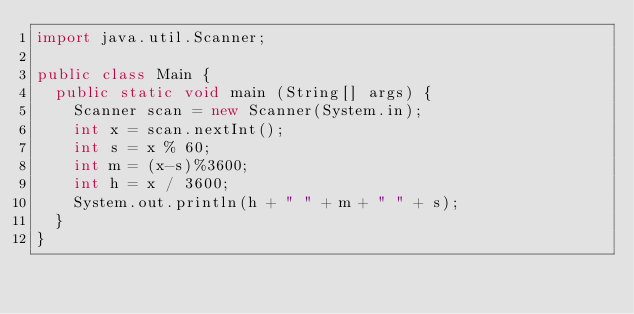Convert code to text. <code><loc_0><loc_0><loc_500><loc_500><_Java_>import java.util.Scanner;

public class Main {
	public static void main (String[] args) {
		Scanner scan = new Scanner(System.in);
		int x = scan.nextInt();
		int s = x % 60;
		int m = (x-s)%3600;
		int h = x / 3600;
		System.out.println(h + " " + m + " " + s);
	}
}</code> 